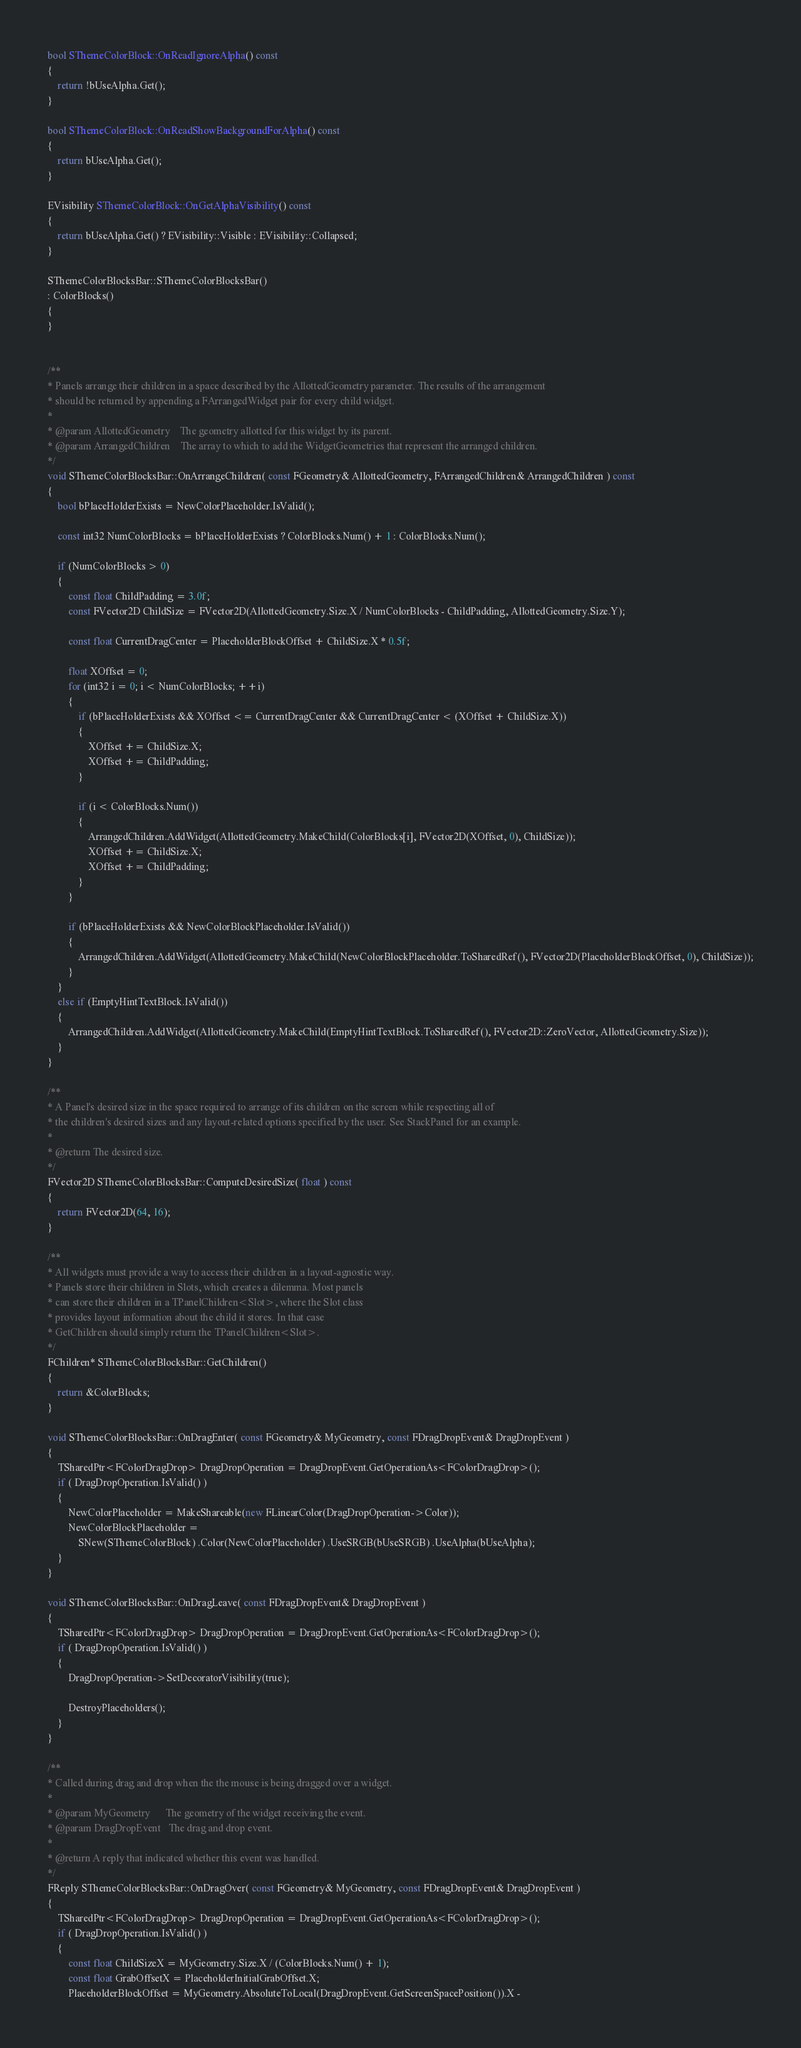<code> <loc_0><loc_0><loc_500><loc_500><_C++_>
bool SThemeColorBlock::OnReadIgnoreAlpha() const
{
	return !bUseAlpha.Get();
}

bool SThemeColorBlock::OnReadShowBackgroundForAlpha() const
{
	return bUseAlpha.Get();
}

EVisibility SThemeColorBlock::OnGetAlphaVisibility() const
{
	return bUseAlpha.Get() ? EVisibility::Visible : EVisibility::Collapsed;
}

SThemeColorBlocksBar::SThemeColorBlocksBar()
: ColorBlocks()
{
}


/**
* Panels arrange their children in a space described by the AllottedGeometry parameter. The results of the arrangement
* should be returned by appending a FArrangedWidget pair for every child widget.
*
* @param AllottedGeometry    The geometry allotted for this widget by its parent.
* @param ArrangedChildren    The array to which to add the WidgetGeometries that represent the arranged children.
*/
void SThemeColorBlocksBar::OnArrangeChildren( const FGeometry& AllottedGeometry, FArrangedChildren& ArrangedChildren ) const
{
	bool bPlaceHolderExists = NewColorPlaceholder.IsValid();

	const int32 NumColorBlocks = bPlaceHolderExists ? ColorBlocks.Num() + 1 : ColorBlocks.Num();

	if (NumColorBlocks > 0)
	{
		const float ChildPadding = 3.0f;
		const FVector2D ChildSize = FVector2D(AllottedGeometry.Size.X / NumColorBlocks - ChildPadding, AllottedGeometry.Size.Y);

		const float CurrentDragCenter = PlaceholderBlockOffset + ChildSize.X * 0.5f;

		float XOffset = 0;
		for (int32 i = 0; i < NumColorBlocks; ++i)
		{
			if (bPlaceHolderExists && XOffset <= CurrentDragCenter && CurrentDragCenter < (XOffset + ChildSize.X))
			{
				XOffset += ChildSize.X;
				XOffset += ChildPadding;
			}

			if (i < ColorBlocks.Num())
			{
				ArrangedChildren.AddWidget(AllottedGeometry.MakeChild(ColorBlocks[i], FVector2D(XOffset, 0), ChildSize));
				XOffset += ChildSize.X;
				XOffset += ChildPadding;
			}
		}

		if (bPlaceHolderExists && NewColorBlockPlaceholder.IsValid())
		{
			ArrangedChildren.AddWidget(AllottedGeometry.MakeChild(NewColorBlockPlaceholder.ToSharedRef(), FVector2D(PlaceholderBlockOffset, 0), ChildSize));
		}
	}
	else if (EmptyHintTextBlock.IsValid())
	{
		ArrangedChildren.AddWidget(AllottedGeometry.MakeChild(EmptyHintTextBlock.ToSharedRef(), FVector2D::ZeroVector, AllottedGeometry.Size));
	}
}

/**
* A Panel's desired size in the space required to arrange of its children on the screen while respecting all of
* the children's desired sizes and any layout-related options specified by the user. See StackPanel for an example.
*
* @return The desired size.
*/
FVector2D SThemeColorBlocksBar::ComputeDesiredSize( float ) const
{
	return FVector2D(64, 16);
}

/**
* All widgets must provide a way to access their children in a layout-agnostic way.
* Panels store their children in Slots, which creates a dilemma. Most panels
* can store their children in a TPanelChildren<Slot>, where the Slot class
* provides layout information about the child it stores. In that case
* GetChildren should simply return the TPanelChildren<Slot>.
*/
FChildren* SThemeColorBlocksBar::GetChildren()
{
	return &ColorBlocks;
}

void SThemeColorBlocksBar::OnDragEnter( const FGeometry& MyGeometry, const FDragDropEvent& DragDropEvent )
{
	TSharedPtr<FColorDragDrop> DragDropOperation = DragDropEvent.GetOperationAs<FColorDragDrop>();
	if ( DragDropOperation.IsValid() )
	{
		NewColorPlaceholder = MakeShareable(new FLinearColor(DragDropOperation->Color));
		NewColorBlockPlaceholder =
			SNew(SThemeColorBlock) .Color(NewColorPlaceholder) .UseSRGB(bUseSRGB) .UseAlpha(bUseAlpha);
	}
}

void SThemeColorBlocksBar::OnDragLeave( const FDragDropEvent& DragDropEvent )
{
	TSharedPtr<FColorDragDrop> DragDropOperation = DragDropEvent.GetOperationAs<FColorDragDrop>();
	if ( DragDropOperation.IsValid() )
	{
		DragDropOperation->SetDecoratorVisibility(true);

		DestroyPlaceholders();
	}
}

/**
* Called during drag and drop when the the mouse is being dragged over a widget.
*
* @param MyGeometry      The geometry of the widget receiving the event.
* @param DragDropEvent   The drag and drop event.
*
* @return A reply that indicated whether this event was handled.
*/
FReply SThemeColorBlocksBar::OnDragOver( const FGeometry& MyGeometry, const FDragDropEvent& DragDropEvent )
{
	TSharedPtr<FColorDragDrop> DragDropOperation = DragDropEvent.GetOperationAs<FColorDragDrop>();
	if ( DragDropOperation.IsValid() )
	{
		const float ChildSizeX = MyGeometry.Size.X / (ColorBlocks.Num() + 1);
		const float GrabOffsetX = PlaceholderInitialGrabOffset.X;
		PlaceholderBlockOffset = MyGeometry.AbsoluteToLocal(DragDropEvent.GetScreenSpacePosition()).X -</code> 